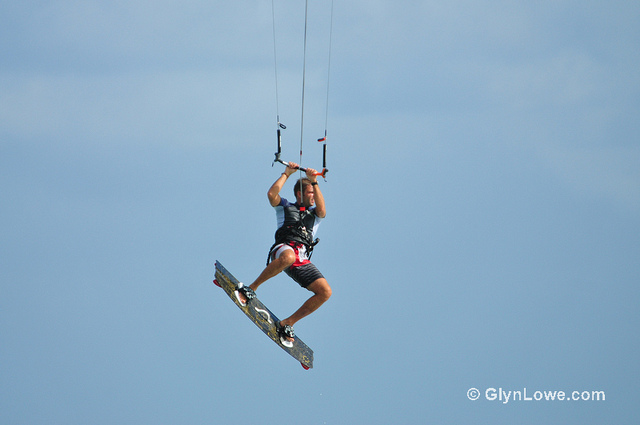Read and extract the text from this image. GlynLowe.com 